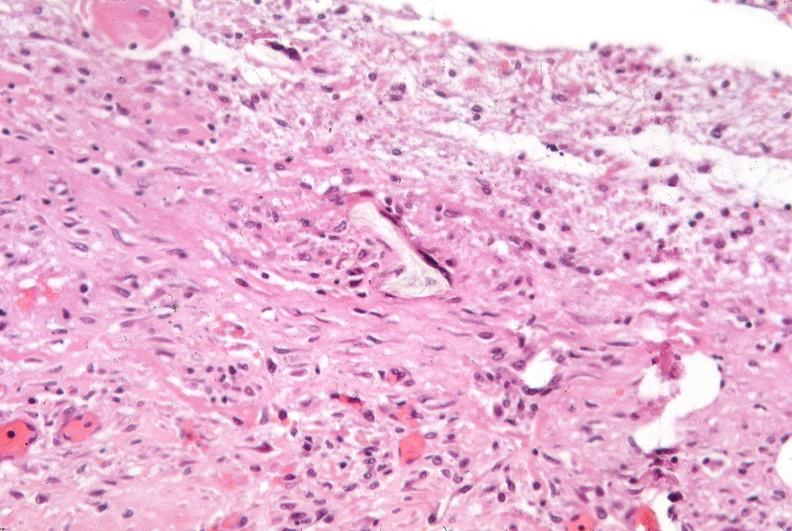does this image show pleura, talc reaction?
Answer the question using a single word or phrase. Yes 